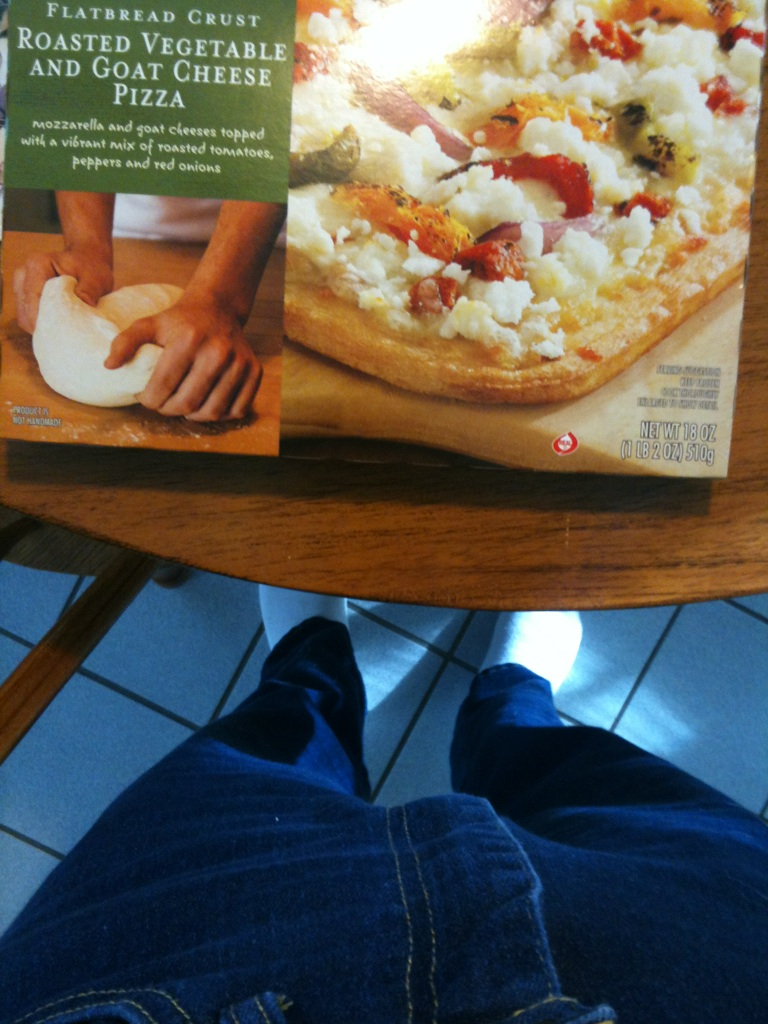How can I serve this pizza to make it a full meal? To make this pizza a full meal, consider pairing it with a fresh side salad or some steamed vegetables. Adding a light soup, like a tomato basil or a minestrone, could also complement the pizza's flavors nicely. What type of wine pairs well with this pizza? A light white wine, such as Pinot Grigio or Sauvignon Blanc, would pair wonderfully with this pizza. These wines balance the richness of the goat cheese and the sweetness of the roasted vegetables perfectly. 